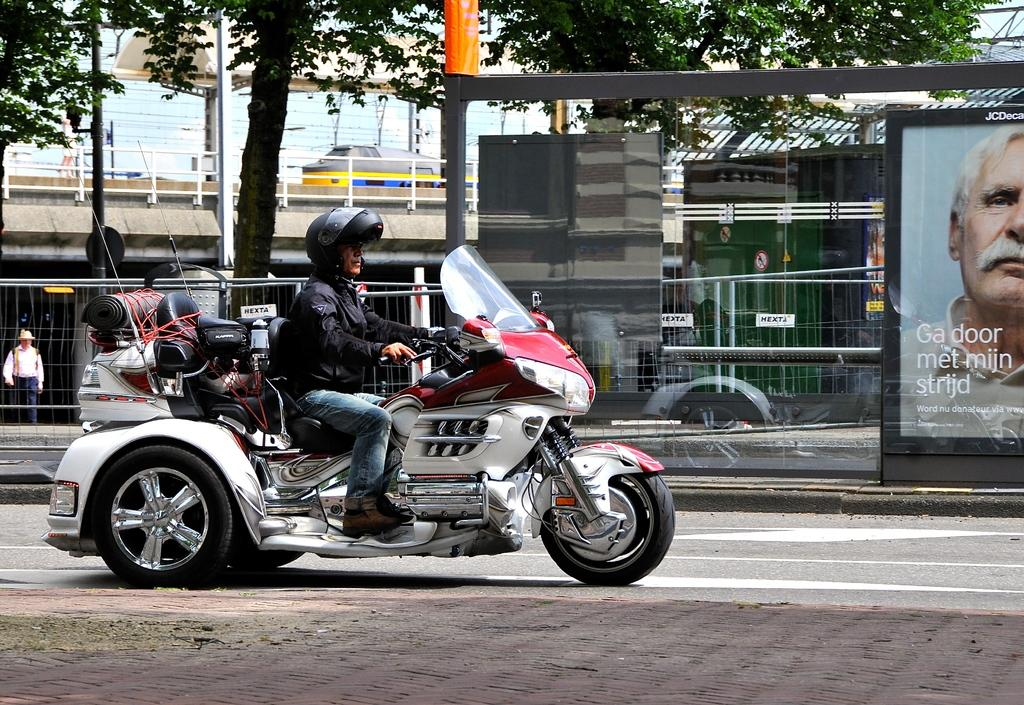What is the man doing in the image? The man is riding a motorcycle in the image. Where is the man riding the motorcycle? The man is on a road in the image. What can be seen in the background of the image? There is a hoarding, a building, a train, and trees in the image. How many letters are visible on the man's head in the image? There are no letters visible on the man's head in the image. 